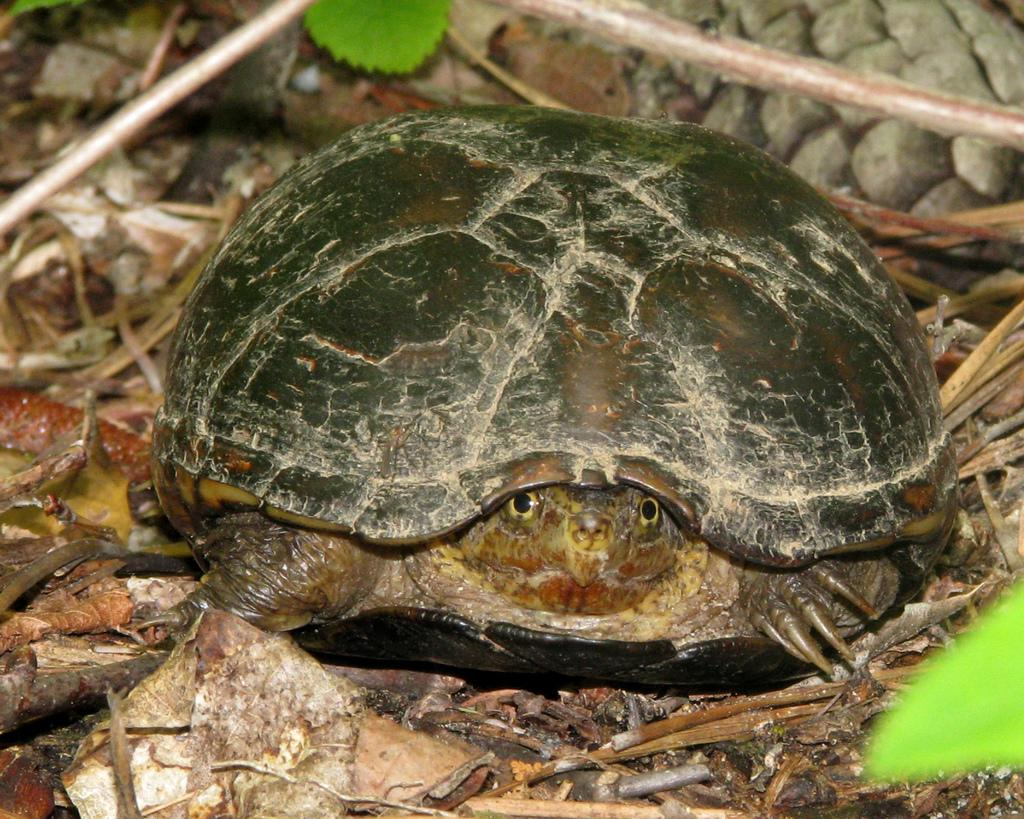What is the main subject in the center of the image? There is a tortoise in the center of the image. What can be seen in the background of the image? There are leaves and thin sticks in the background of the image. What type of sack is being used to carry the tortoise in the image? There is no sack present in the image; the tortoise is not being carried. 